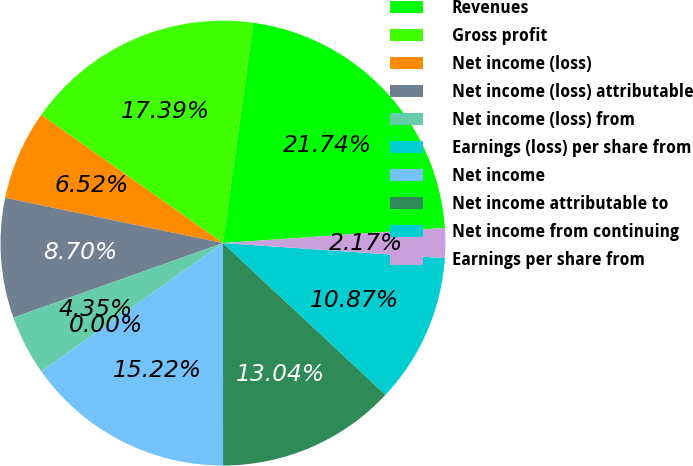Convert chart to OTSL. <chart><loc_0><loc_0><loc_500><loc_500><pie_chart><fcel>Revenues<fcel>Gross profit<fcel>Net income (loss)<fcel>Net income (loss) attributable<fcel>Net income (loss) from<fcel>Earnings (loss) per share from<fcel>Net income<fcel>Net income attributable to<fcel>Net income from continuing<fcel>Earnings per share from<nl><fcel>21.74%<fcel>17.39%<fcel>6.52%<fcel>8.7%<fcel>4.35%<fcel>0.0%<fcel>15.22%<fcel>13.04%<fcel>10.87%<fcel>2.17%<nl></chart> 